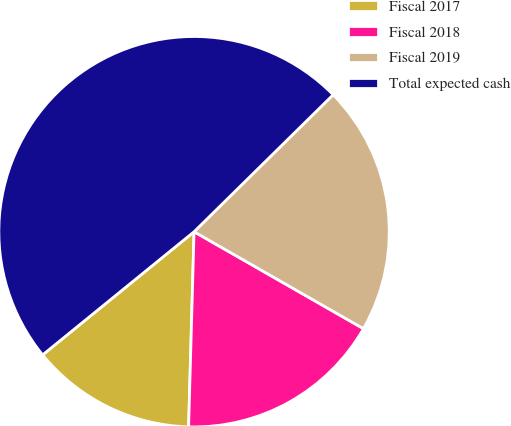Convert chart to OTSL. <chart><loc_0><loc_0><loc_500><loc_500><pie_chart><fcel>Fiscal 2017<fcel>Fiscal 2018<fcel>Fiscal 2019<fcel>Total expected cash<nl><fcel>13.69%<fcel>17.17%<fcel>20.65%<fcel>48.49%<nl></chart> 